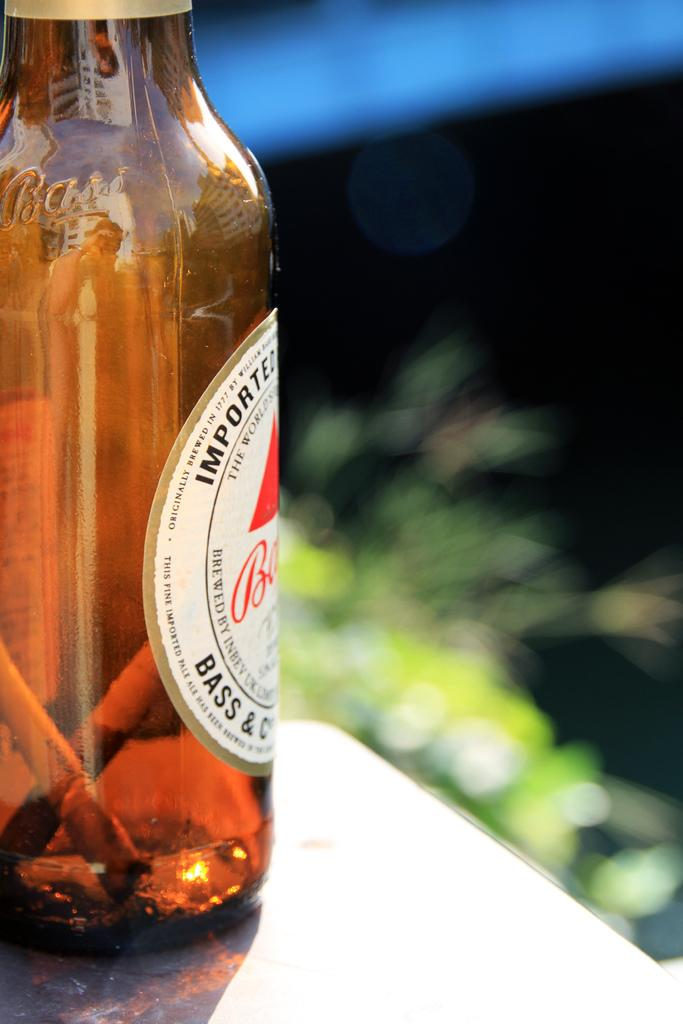Provide a one-sentence caption for the provided image. A brown bottle of Bass Ale beer on a counter. 